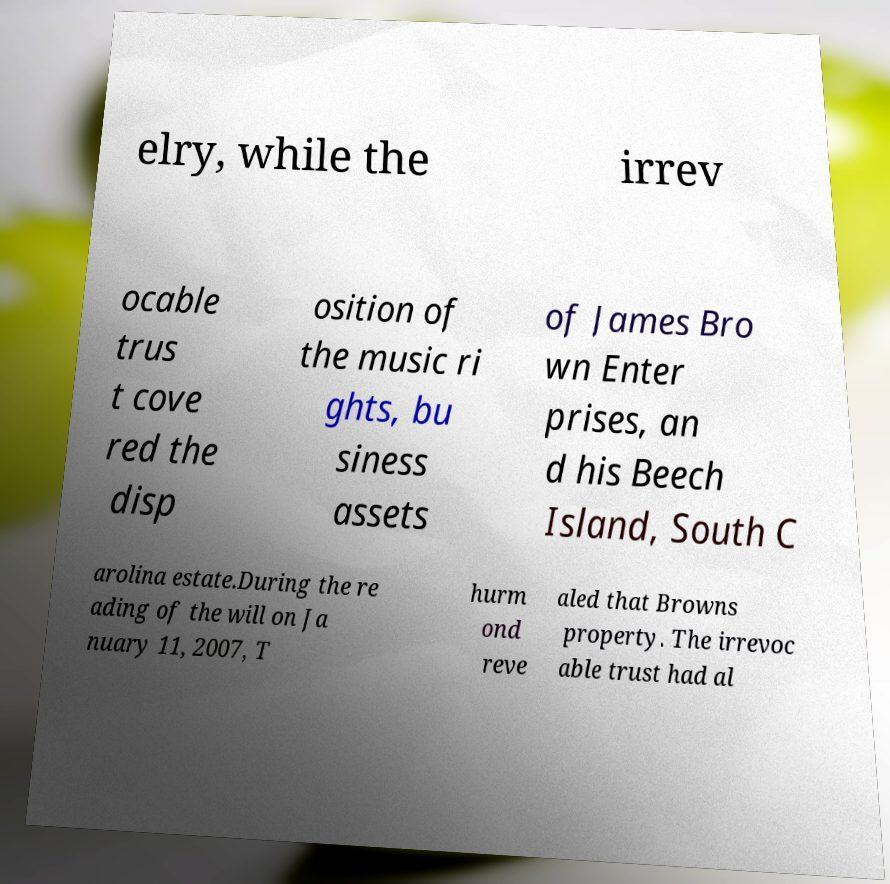Could you extract and type out the text from this image? elry, while the irrev ocable trus t cove red the disp osition of the music ri ghts, bu siness assets of James Bro wn Enter prises, an d his Beech Island, South C arolina estate.During the re ading of the will on Ja nuary 11, 2007, T hurm ond reve aled that Browns property. The irrevoc able trust had al 